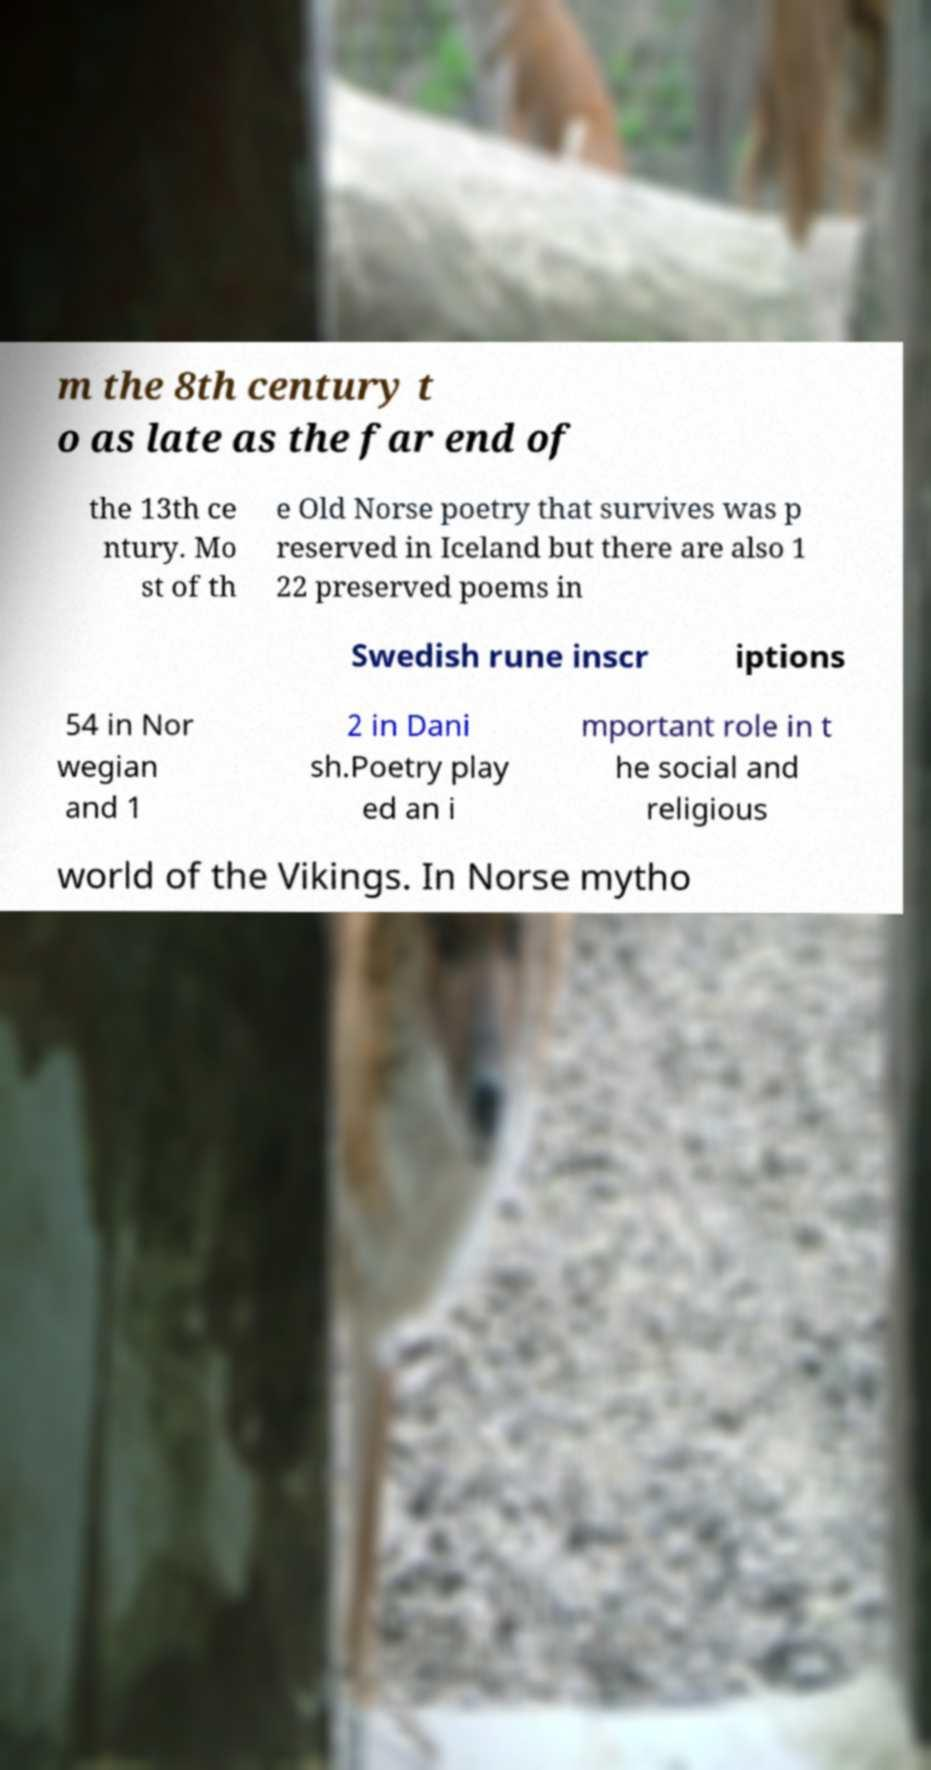For documentation purposes, I need the text within this image transcribed. Could you provide that? m the 8th century t o as late as the far end of the 13th ce ntury. Mo st of th e Old Norse poetry that survives was p reserved in Iceland but there are also 1 22 preserved poems in Swedish rune inscr iptions 54 in Nor wegian and 1 2 in Dani sh.Poetry play ed an i mportant role in t he social and religious world of the Vikings. In Norse mytho 